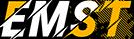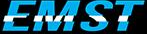Identify the words shown in these images in order, separated by a semicolon. EMST; EMST 